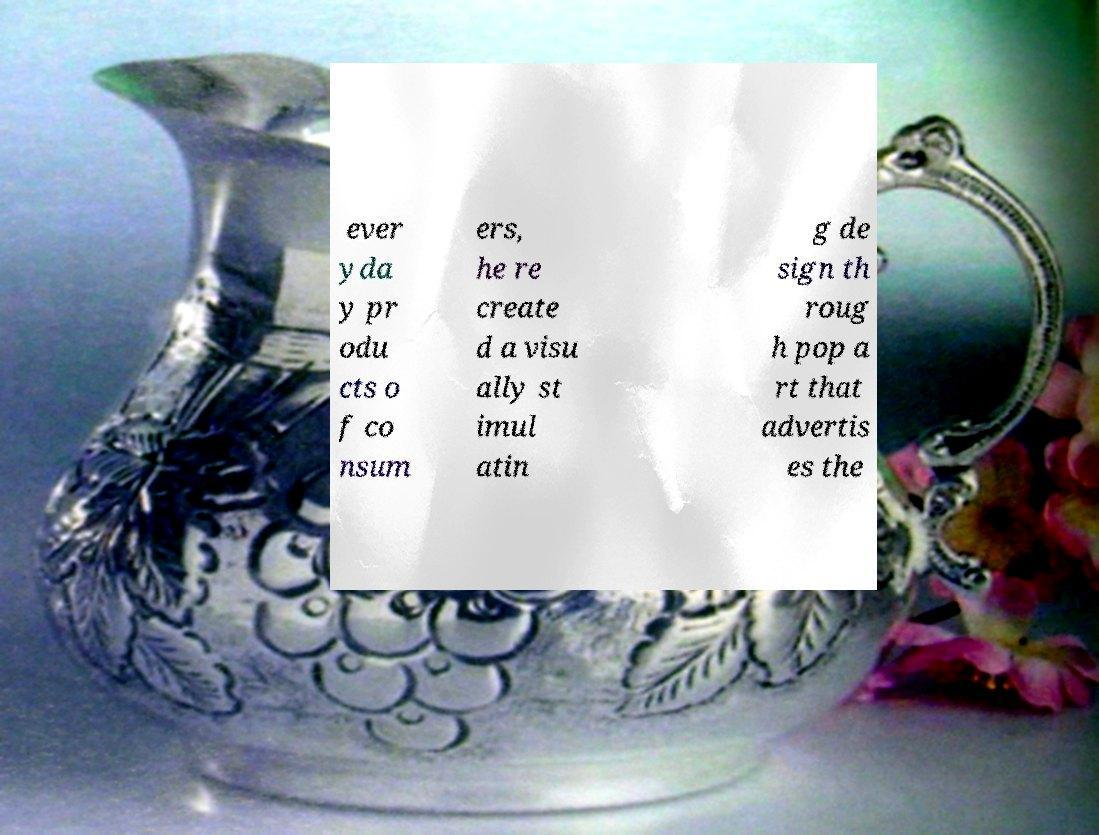I need the written content from this picture converted into text. Can you do that? ever yda y pr odu cts o f co nsum ers, he re create d a visu ally st imul atin g de sign th roug h pop a rt that advertis es the 